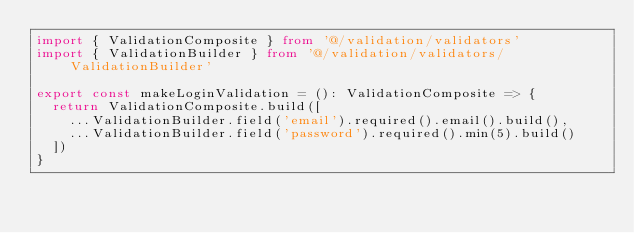Convert code to text. <code><loc_0><loc_0><loc_500><loc_500><_TypeScript_>import { ValidationComposite } from '@/validation/validators'
import { ValidationBuilder } from '@/validation/validators/ValidationBuilder'

export const makeLoginValidation = (): ValidationComposite => {
  return ValidationComposite.build([
    ...ValidationBuilder.field('email').required().email().build(),
    ...ValidationBuilder.field('password').required().min(5).build()
  ])
}
</code> 